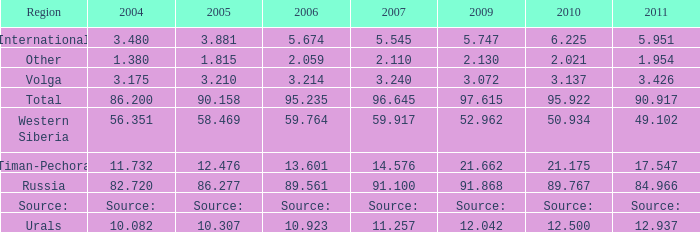Would you mind parsing the complete table? {'header': ['Region', '2004', '2005', '2006', '2007', '2009', '2010', '2011'], 'rows': [['International', '3.480', '3.881', '5.674', '5.545', '5.747', '6.225', '5.951'], ['Other', '1.380', '1.815', '2.059', '2.110', '2.130', '2.021', '1.954'], ['Volga', '3.175', '3.210', '3.214', '3.240', '3.072', '3.137', '3.426'], ['Total', '86.200', '90.158', '95.235', '96.645', '97.615', '95.922', '90.917'], ['Western Siberia', '56.351', '58.469', '59.764', '59.917', '52.962', '50.934', '49.102'], ['Timan-Pechora', '11.732', '12.476', '13.601', '14.576', '21.662', '21.175', '17.547'], ['Russia', '82.720', '86.277', '89.561', '91.100', '91.868', '89.767', '84.966'], ['Source:', 'Source:', 'Source:', 'Source:', 'Source:', 'Source:', 'Source:', 'Source:'], ['Urals', '10.082', '10.307', '10.923', '11.257', '12.042', '12.500', '12.937']]} What is the 2010 Lukoil oil prodroduction when in 2009 oil production 21.662 million tonnes? 21.175. 